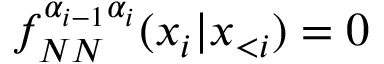Convert formula to latex. <formula><loc_0><loc_0><loc_500><loc_500>f _ { N N } ^ { \alpha _ { i - 1 } \alpha _ { i } } ( x _ { i } | \boldsymbol x _ { < i } ) = 0</formula> 